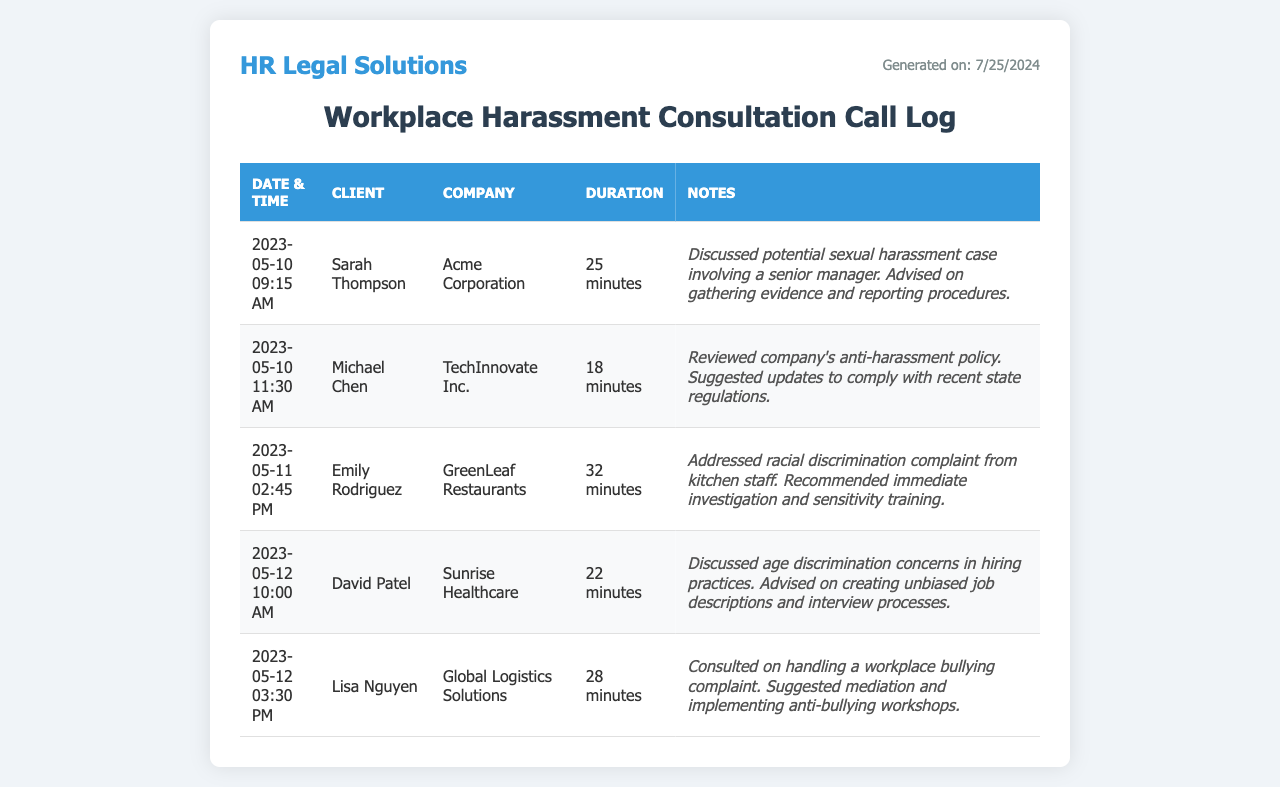What is the date of the first call logged? The first call logged is on May 10, 2023.
Answer: May 10, 2023 Who is the client in the second call? The second call is with Michael Chen.
Answer: Michael Chen What is the total duration of the calls involving Sarah Thompson and Emily Rodriguez? Sarah's call lasted 25 minutes, and Emily's call lasted 32 minutes, summing to 57 minutes.
Answer: 57 minutes What company is associated with Lisa Nguyen? Lisa Nguyen is associated with Global Logistics Solutions.
Answer: Global Logistics Solutions What type of harassment was addressed in the call with Emily Rodriguez? The call with Emily Rodriguez addressed racial discrimination.
Answer: Racial discrimination How many minutes did the consultation with David Patel last? The consultation with David Patel lasted for 22 minutes.
Answer: 22 minutes What advice was given to Sarah Thompson regarding her case? Sarah was advised on gathering evidence and reporting procedures.
Answer: Gathering evidence and reporting procedures Which company had a call about an anti-harassment policy? The call regarding an anti-harassment policy was with TechInnovate Inc.
Answer: TechInnovate Inc What was suggested to handle the workplace bullying complaint discussed in Lisa Nguyen's call? Mediation and implementing anti-bullying workshops were suggested.
Answer: Mediation and implementing anti-bullying workshops 